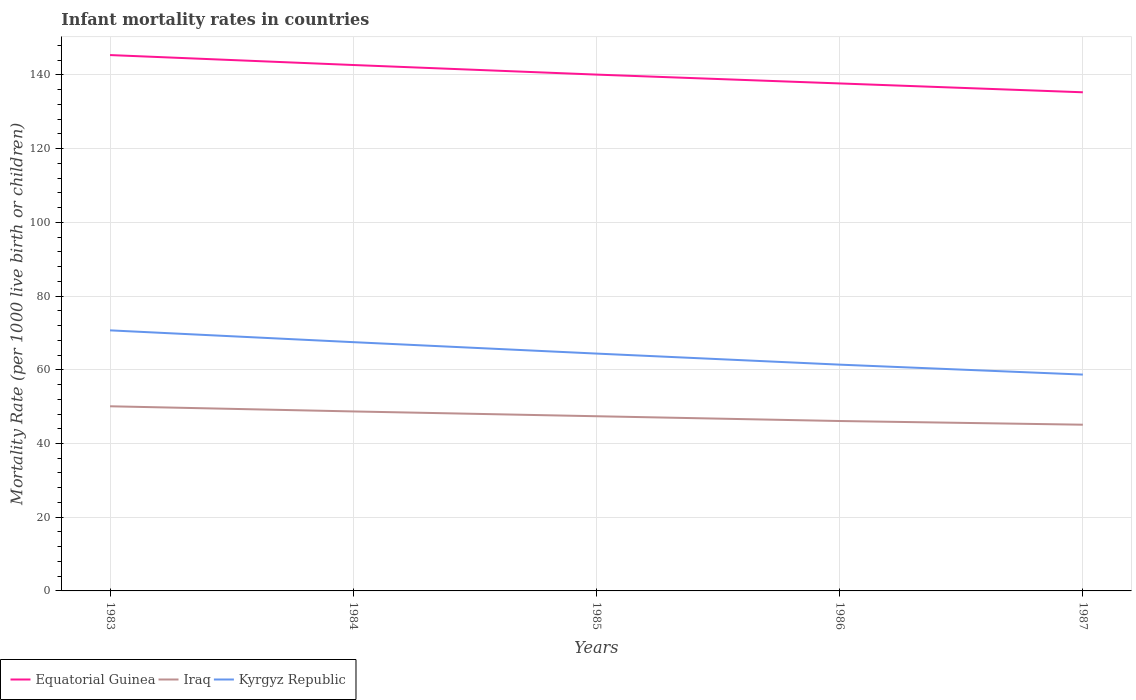Across all years, what is the maximum infant mortality rate in Equatorial Guinea?
Provide a short and direct response. 135.3. In which year was the infant mortality rate in Kyrgyz Republic maximum?
Provide a short and direct response. 1987. What is the difference between the highest and the second highest infant mortality rate in Kyrgyz Republic?
Your response must be concise. 12. Is the infant mortality rate in Iraq strictly greater than the infant mortality rate in Kyrgyz Republic over the years?
Your answer should be compact. Yes. How many lines are there?
Give a very brief answer. 3. How many years are there in the graph?
Provide a succinct answer. 5. Are the values on the major ticks of Y-axis written in scientific E-notation?
Give a very brief answer. No. Where does the legend appear in the graph?
Your answer should be very brief. Bottom left. How are the legend labels stacked?
Keep it short and to the point. Horizontal. What is the title of the graph?
Your answer should be very brief. Infant mortality rates in countries. Does "Senegal" appear as one of the legend labels in the graph?
Offer a very short reply. No. What is the label or title of the X-axis?
Your answer should be very brief. Years. What is the label or title of the Y-axis?
Keep it short and to the point. Mortality Rate (per 1000 live birth or children). What is the Mortality Rate (per 1000 live birth or children) of Equatorial Guinea in 1983?
Provide a succinct answer. 145.4. What is the Mortality Rate (per 1000 live birth or children) of Iraq in 1983?
Keep it short and to the point. 50.1. What is the Mortality Rate (per 1000 live birth or children) in Kyrgyz Republic in 1983?
Offer a terse response. 70.7. What is the Mortality Rate (per 1000 live birth or children) in Equatorial Guinea in 1984?
Give a very brief answer. 142.7. What is the Mortality Rate (per 1000 live birth or children) in Iraq in 1984?
Provide a succinct answer. 48.7. What is the Mortality Rate (per 1000 live birth or children) in Kyrgyz Republic in 1984?
Offer a terse response. 67.5. What is the Mortality Rate (per 1000 live birth or children) in Equatorial Guinea in 1985?
Provide a succinct answer. 140.1. What is the Mortality Rate (per 1000 live birth or children) in Iraq in 1985?
Your answer should be compact. 47.4. What is the Mortality Rate (per 1000 live birth or children) of Kyrgyz Republic in 1985?
Offer a very short reply. 64.4. What is the Mortality Rate (per 1000 live birth or children) of Equatorial Guinea in 1986?
Make the answer very short. 137.7. What is the Mortality Rate (per 1000 live birth or children) in Iraq in 1986?
Your response must be concise. 46.1. What is the Mortality Rate (per 1000 live birth or children) in Kyrgyz Republic in 1986?
Make the answer very short. 61.4. What is the Mortality Rate (per 1000 live birth or children) in Equatorial Guinea in 1987?
Your response must be concise. 135.3. What is the Mortality Rate (per 1000 live birth or children) of Iraq in 1987?
Give a very brief answer. 45.1. What is the Mortality Rate (per 1000 live birth or children) of Kyrgyz Republic in 1987?
Keep it short and to the point. 58.7. Across all years, what is the maximum Mortality Rate (per 1000 live birth or children) of Equatorial Guinea?
Your answer should be very brief. 145.4. Across all years, what is the maximum Mortality Rate (per 1000 live birth or children) of Iraq?
Make the answer very short. 50.1. Across all years, what is the maximum Mortality Rate (per 1000 live birth or children) of Kyrgyz Republic?
Your answer should be compact. 70.7. Across all years, what is the minimum Mortality Rate (per 1000 live birth or children) in Equatorial Guinea?
Your answer should be compact. 135.3. Across all years, what is the minimum Mortality Rate (per 1000 live birth or children) in Iraq?
Keep it short and to the point. 45.1. Across all years, what is the minimum Mortality Rate (per 1000 live birth or children) in Kyrgyz Republic?
Offer a very short reply. 58.7. What is the total Mortality Rate (per 1000 live birth or children) of Equatorial Guinea in the graph?
Your response must be concise. 701.2. What is the total Mortality Rate (per 1000 live birth or children) in Iraq in the graph?
Your answer should be very brief. 237.4. What is the total Mortality Rate (per 1000 live birth or children) in Kyrgyz Republic in the graph?
Keep it short and to the point. 322.7. What is the difference between the Mortality Rate (per 1000 live birth or children) of Iraq in 1983 and that in 1984?
Keep it short and to the point. 1.4. What is the difference between the Mortality Rate (per 1000 live birth or children) in Equatorial Guinea in 1983 and that in 1985?
Your answer should be compact. 5.3. What is the difference between the Mortality Rate (per 1000 live birth or children) of Kyrgyz Republic in 1983 and that in 1986?
Give a very brief answer. 9.3. What is the difference between the Mortality Rate (per 1000 live birth or children) of Iraq in 1983 and that in 1987?
Offer a very short reply. 5. What is the difference between the Mortality Rate (per 1000 live birth or children) in Equatorial Guinea in 1984 and that in 1985?
Give a very brief answer. 2.6. What is the difference between the Mortality Rate (per 1000 live birth or children) of Iraq in 1984 and that in 1985?
Give a very brief answer. 1.3. What is the difference between the Mortality Rate (per 1000 live birth or children) of Kyrgyz Republic in 1984 and that in 1985?
Keep it short and to the point. 3.1. What is the difference between the Mortality Rate (per 1000 live birth or children) in Equatorial Guinea in 1984 and that in 1986?
Ensure brevity in your answer.  5. What is the difference between the Mortality Rate (per 1000 live birth or children) of Iraq in 1984 and that in 1986?
Ensure brevity in your answer.  2.6. What is the difference between the Mortality Rate (per 1000 live birth or children) in Kyrgyz Republic in 1984 and that in 1986?
Make the answer very short. 6.1. What is the difference between the Mortality Rate (per 1000 live birth or children) in Equatorial Guinea in 1984 and that in 1987?
Provide a succinct answer. 7.4. What is the difference between the Mortality Rate (per 1000 live birth or children) in Iraq in 1984 and that in 1987?
Provide a short and direct response. 3.6. What is the difference between the Mortality Rate (per 1000 live birth or children) of Kyrgyz Republic in 1984 and that in 1987?
Offer a terse response. 8.8. What is the difference between the Mortality Rate (per 1000 live birth or children) of Equatorial Guinea in 1985 and that in 1986?
Provide a short and direct response. 2.4. What is the difference between the Mortality Rate (per 1000 live birth or children) of Iraq in 1985 and that in 1986?
Give a very brief answer. 1.3. What is the difference between the Mortality Rate (per 1000 live birth or children) in Kyrgyz Republic in 1985 and that in 1986?
Your answer should be very brief. 3. What is the difference between the Mortality Rate (per 1000 live birth or children) of Equatorial Guinea in 1986 and that in 1987?
Provide a succinct answer. 2.4. What is the difference between the Mortality Rate (per 1000 live birth or children) in Equatorial Guinea in 1983 and the Mortality Rate (per 1000 live birth or children) in Iraq in 1984?
Ensure brevity in your answer.  96.7. What is the difference between the Mortality Rate (per 1000 live birth or children) in Equatorial Guinea in 1983 and the Mortality Rate (per 1000 live birth or children) in Kyrgyz Republic in 1984?
Your response must be concise. 77.9. What is the difference between the Mortality Rate (per 1000 live birth or children) in Iraq in 1983 and the Mortality Rate (per 1000 live birth or children) in Kyrgyz Republic in 1984?
Give a very brief answer. -17.4. What is the difference between the Mortality Rate (per 1000 live birth or children) in Equatorial Guinea in 1983 and the Mortality Rate (per 1000 live birth or children) in Iraq in 1985?
Give a very brief answer. 98. What is the difference between the Mortality Rate (per 1000 live birth or children) in Equatorial Guinea in 1983 and the Mortality Rate (per 1000 live birth or children) in Kyrgyz Republic in 1985?
Ensure brevity in your answer.  81. What is the difference between the Mortality Rate (per 1000 live birth or children) of Iraq in 1983 and the Mortality Rate (per 1000 live birth or children) of Kyrgyz Republic in 1985?
Make the answer very short. -14.3. What is the difference between the Mortality Rate (per 1000 live birth or children) in Equatorial Guinea in 1983 and the Mortality Rate (per 1000 live birth or children) in Iraq in 1986?
Your response must be concise. 99.3. What is the difference between the Mortality Rate (per 1000 live birth or children) in Equatorial Guinea in 1983 and the Mortality Rate (per 1000 live birth or children) in Kyrgyz Republic in 1986?
Provide a succinct answer. 84. What is the difference between the Mortality Rate (per 1000 live birth or children) in Iraq in 1983 and the Mortality Rate (per 1000 live birth or children) in Kyrgyz Republic in 1986?
Provide a short and direct response. -11.3. What is the difference between the Mortality Rate (per 1000 live birth or children) of Equatorial Guinea in 1983 and the Mortality Rate (per 1000 live birth or children) of Iraq in 1987?
Offer a terse response. 100.3. What is the difference between the Mortality Rate (per 1000 live birth or children) in Equatorial Guinea in 1983 and the Mortality Rate (per 1000 live birth or children) in Kyrgyz Republic in 1987?
Offer a very short reply. 86.7. What is the difference between the Mortality Rate (per 1000 live birth or children) of Iraq in 1983 and the Mortality Rate (per 1000 live birth or children) of Kyrgyz Republic in 1987?
Give a very brief answer. -8.6. What is the difference between the Mortality Rate (per 1000 live birth or children) in Equatorial Guinea in 1984 and the Mortality Rate (per 1000 live birth or children) in Iraq in 1985?
Provide a short and direct response. 95.3. What is the difference between the Mortality Rate (per 1000 live birth or children) in Equatorial Guinea in 1984 and the Mortality Rate (per 1000 live birth or children) in Kyrgyz Republic in 1985?
Offer a terse response. 78.3. What is the difference between the Mortality Rate (per 1000 live birth or children) in Iraq in 1984 and the Mortality Rate (per 1000 live birth or children) in Kyrgyz Republic in 1985?
Offer a very short reply. -15.7. What is the difference between the Mortality Rate (per 1000 live birth or children) in Equatorial Guinea in 1984 and the Mortality Rate (per 1000 live birth or children) in Iraq in 1986?
Offer a terse response. 96.6. What is the difference between the Mortality Rate (per 1000 live birth or children) in Equatorial Guinea in 1984 and the Mortality Rate (per 1000 live birth or children) in Kyrgyz Republic in 1986?
Give a very brief answer. 81.3. What is the difference between the Mortality Rate (per 1000 live birth or children) of Iraq in 1984 and the Mortality Rate (per 1000 live birth or children) of Kyrgyz Republic in 1986?
Give a very brief answer. -12.7. What is the difference between the Mortality Rate (per 1000 live birth or children) in Equatorial Guinea in 1984 and the Mortality Rate (per 1000 live birth or children) in Iraq in 1987?
Make the answer very short. 97.6. What is the difference between the Mortality Rate (per 1000 live birth or children) of Equatorial Guinea in 1985 and the Mortality Rate (per 1000 live birth or children) of Iraq in 1986?
Make the answer very short. 94. What is the difference between the Mortality Rate (per 1000 live birth or children) in Equatorial Guinea in 1985 and the Mortality Rate (per 1000 live birth or children) in Kyrgyz Republic in 1986?
Your answer should be very brief. 78.7. What is the difference between the Mortality Rate (per 1000 live birth or children) in Iraq in 1985 and the Mortality Rate (per 1000 live birth or children) in Kyrgyz Republic in 1986?
Provide a succinct answer. -14. What is the difference between the Mortality Rate (per 1000 live birth or children) of Equatorial Guinea in 1985 and the Mortality Rate (per 1000 live birth or children) of Kyrgyz Republic in 1987?
Provide a short and direct response. 81.4. What is the difference between the Mortality Rate (per 1000 live birth or children) of Iraq in 1985 and the Mortality Rate (per 1000 live birth or children) of Kyrgyz Republic in 1987?
Provide a short and direct response. -11.3. What is the difference between the Mortality Rate (per 1000 live birth or children) in Equatorial Guinea in 1986 and the Mortality Rate (per 1000 live birth or children) in Iraq in 1987?
Make the answer very short. 92.6. What is the difference between the Mortality Rate (per 1000 live birth or children) in Equatorial Guinea in 1986 and the Mortality Rate (per 1000 live birth or children) in Kyrgyz Republic in 1987?
Your answer should be compact. 79. What is the average Mortality Rate (per 1000 live birth or children) in Equatorial Guinea per year?
Provide a short and direct response. 140.24. What is the average Mortality Rate (per 1000 live birth or children) in Iraq per year?
Keep it short and to the point. 47.48. What is the average Mortality Rate (per 1000 live birth or children) of Kyrgyz Republic per year?
Your answer should be very brief. 64.54. In the year 1983, what is the difference between the Mortality Rate (per 1000 live birth or children) in Equatorial Guinea and Mortality Rate (per 1000 live birth or children) in Iraq?
Ensure brevity in your answer.  95.3. In the year 1983, what is the difference between the Mortality Rate (per 1000 live birth or children) in Equatorial Guinea and Mortality Rate (per 1000 live birth or children) in Kyrgyz Republic?
Give a very brief answer. 74.7. In the year 1983, what is the difference between the Mortality Rate (per 1000 live birth or children) in Iraq and Mortality Rate (per 1000 live birth or children) in Kyrgyz Republic?
Ensure brevity in your answer.  -20.6. In the year 1984, what is the difference between the Mortality Rate (per 1000 live birth or children) of Equatorial Guinea and Mortality Rate (per 1000 live birth or children) of Iraq?
Give a very brief answer. 94. In the year 1984, what is the difference between the Mortality Rate (per 1000 live birth or children) of Equatorial Guinea and Mortality Rate (per 1000 live birth or children) of Kyrgyz Republic?
Your response must be concise. 75.2. In the year 1984, what is the difference between the Mortality Rate (per 1000 live birth or children) in Iraq and Mortality Rate (per 1000 live birth or children) in Kyrgyz Republic?
Make the answer very short. -18.8. In the year 1985, what is the difference between the Mortality Rate (per 1000 live birth or children) of Equatorial Guinea and Mortality Rate (per 1000 live birth or children) of Iraq?
Ensure brevity in your answer.  92.7. In the year 1985, what is the difference between the Mortality Rate (per 1000 live birth or children) in Equatorial Guinea and Mortality Rate (per 1000 live birth or children) in Kyrgyz Republic?
Provide a short and direct response. 75.7. In the year 1986, what is the difference between the Mortality Rate (per 1000 live birth or children) of Equatorial Guinea and Mortality Rate (per 1000 live birth or children) of Iraq?
Keep it short and to the point. 91.6. In the year 1986, what is the difference between the Mortality Rate (per 1000 live birth or children) in Equatorial Guinea and Mortality Rate (per 1000 live birth or children) in Kyrgyz Republic?
Offer a very short reply. 76.3. In the year 1986, what is the difference between the Mortality Rate (per 1000 live birth or children) in Iraq and Mortality Rate (per 1000 live birth or children) in Kyrgyz Republic?
Give a very brief answer. -15.3. In the year 1987, what is the difference between the Mortality Rate (per 1000 live birth or children) in Equatorial Guinea and Mortality Rate (per 1000 live birth or children) in Iraq?
Provide a succinct answer. 90.2. In the year 1987, what is the difference between the Mortality Rate (per 1000 live birth or children) in Equatorial Guinea and Mortality Rate (per 1000 live birth or children) in Kyrgyz Republic?
Your response must be concise. 76.6. What is the ratio of the Mortality Rate (per 1000 live birth or children) in Equatorial Guinea in 1983 to that in 1984?
Make the answer very short. 1.02. What is the ratio of the Mortality Rate (per 1000 live birth or children) in Iraq in 1983 to that in 1984?
Offer a very short reply. 1.03. What is the ratio of the Mortality Rate (per 1000 live birth or children) in Kyrgyz Republic in 1983 to that in 1984?
Give a very brief answer. 1.05. What is the ratio of the Mortality Rate (per 1000 live birth or children) in Equatorial Guinea in 1983 to that in 1985?
Your response must be concise. 1.04. What is the ratio of the Mortality Rate (per 1000 live birth or children) in Iraq in 1983 to that in 1985?
Give a very brief answer. 1.06. What is the ratio of the Mortality Rate (per 1000 live birth or children) of Kyrgyz Republic in 1983 to that in 1985?
Ensure brevity in your answer.  1.1. What is the ratio of the Mortality Rate (per 1000 live birth or children) in Equatorial Guinea in 1983 to that in 1986?
Offer a terse response. 1.06. What is the ratio of the Mortality Rate (per 1000 live birth or children) of Iraq in 1983 to that in 1986?
Provide a succinct answer. 1.09. What is the ratio of the Mortality Rate (per 1000 live birth or children) in Kyrgyz Republic in 1983 to that in 1986?
Keep it short and to the point. 1.15. What is the ratio of the Mortality Rate (per 1000 live birth or children) in Equatorial Guinea in 1983 to that in 1987?
Your response must be concise. 1.07. What is the ratio of the Mortality Rate (per 1000 live birth or children) in Iraq in 1983 to that in 1987?
Ensure brevity in your answer.  1.11. What is the ratio of the Mortality Rate (per 1000 live birth or children) of Kyrgyz Republic in 1983 to that in 1987?
Provide a succinct answer. 1.2. What is the ratio of the Mortality Rate (per 1000 live birth or children) of Equatorial Guinea in 1984 to that in 1985?
Offer a very short reply. 1.02. What is the ratio of the Mortality Rate (per 1000 live birth or children) of Iraq in 1984 to that in 1985?
Keep it short and to the point. 1.03. What is the ratio of the Mortality Rate (per 1000 live birth or children) of Kyrgyz Republic in 1984 to that in 1985?
Offer a very short reply. 1.05. What is the ratio of the Mortality Rate (per 1000 live birth or children) in Equatorial Guinea in 1984 to that in 1986?
Your answer should be compact. 1.04. What is the ratio of the Mortality Rate (per 1000 live birth or children) of Iraq in 1984 to that in 1986?
Provide a short and direct response. 1.06. What is the ratio of the Mortality Rate (per 1000 live birth or children) in Kyrgyz Republic in 1984 to that in 1986?
Your response must be concise. 1.1. What is the ratio of the Mortality Rate (per 1000 live birth or children) in Equatorial Guinea in 1984 to that in 1987?
Your answer should be very brief. 1.05. What is the ratio of the Mortality Rate (per 1000 live birth or children) of Iraq in 1984 to that in 1987?
Offer a very short reply. 1.08. What is the ratio of the Mortality Rate (per 1000 live birth or children) of Kyrgyz Republic in 1984 to that in 1987?
Provide a succinct answer. 1.15. What is the ratio of the Mortality Rate (per 1000 live birth or children) of Equatorial Guinea in 1985 to that in 1986?
Ensure brevity in your answer.  1.02. What is the ratio of the Mortality Rate (per 1000 live birth or children) in Iraq in 1985 to that in 1986?
Make the answer very short. 1.03. What is the ratio of the Mortality Rate (per 1000 live birth or children) of Kyrgyz Republic in 1985 to that in 1986?
Keep it short and to the point. 1.05. What is the ratio of the Mortality Rate (per 1000 live birth or children) in Equatorial Guinea in 1985 to that in 1987?
Offer a terse response. 1.04. What is the ratio of the Mortality Rate (per 1000 live birth or children) in Iraq in 1985 to that in 1987?
Provide a short and direct response. 1.05. What is the ratio of the Mortality Rate (per 1000 live birth or children) in Kyrgyz Republic in 1985 to that in 1987?
Provide a succinct answer. 1.1. What is the ratio of the Mortality Rate (per 1000 live birth or children) of Equatorial Guinea in 1986 to that in 1987?
Offer a terse response. 1.02. What is the ratio of the Mortality Rate (per 1000 live birth or children) in Iraq in 1986 to that in 1987?
Ensure brevity in your answer.  1.02. What is the ratio of the Mortality Rate (per 1000 live birth or children) of Kyrgyz Republic in 1986 to that in 1987?
Offer a terse response. 1.05. What is the difference between the highest and the second highest Mortality Rate (per 1000 live birth or children) of Equatorial Guinea?
Your answer should be compact. 2.7. What is the difference between the highest and the second highest Mortality Rate (per 1000 live birth or children) in Kyrgyz Republic?
Make the answer very short. 3.2. What is the difference between the highest and the lowest Mortality Rate (per 1000 live birth or children) of Iraq?
Your response must be concise. 5. 